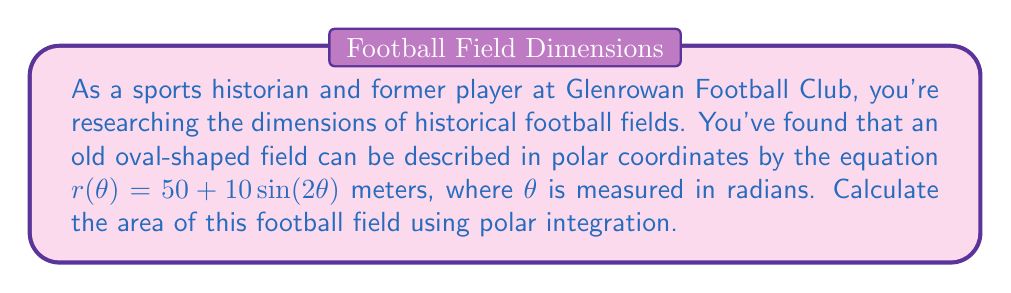Teach me how to tackle this problem. To solve this problem, we'll use the formula for area in polar coordinates and integrate over the full range of $\theta$ from 0 to $2\pi$.

The formula for area in polar coordinates is:

$$ A = \frac{1}{2} \int_a^b [r(\theta)]^2 d\theta $$

Where $r(\theta) = 50 + 10\sin(2\theta)$

Steps:
1) Square the function $r(\theta)$:
   $[r(\theta)]^2 = (50 + 10\sin(2\theta))^2 = 2500 + 1000\sin(2\theta) + 100\sin^2(2\theta)$

2) Set up the integral:
   $$ A = \frac{1}{2} \int_0^{2\pi} (2500 + 1000\sin(2\theta) + 100\sin^2(2\theta)) d\theta $$

3) Integrate each term:
   - $\int_0^{2\pi} 2500 d\theta = 2500\theta \big|_0^{2\pi} = 5000\pi$
   - $\int_0^{2\pi} 1000\sin(2\theta) d\theta = -500\cos(2\theta) \big|_0^{2\pi} = 0$
   - $\int_0^{2\pi} 100\sin^2(2\theta) d\theta = 50\int_0^{2\pi} (1 - \cos(4\theta)) d\theta = 50\theta - \frac{25}{2}\sin(4\theta) \big|_0^{2\pi} = 100\pi$

4) Sum the results and multiply by $\frac{1}{2}$:
   $$ A = \frac{1}{2} (5000\pi + 0 + 100\pi) = 2550\pi $$

Therefore, the area of the football field is $2550\pi$ square meters.
Answer: $2550\pi$ square meters 